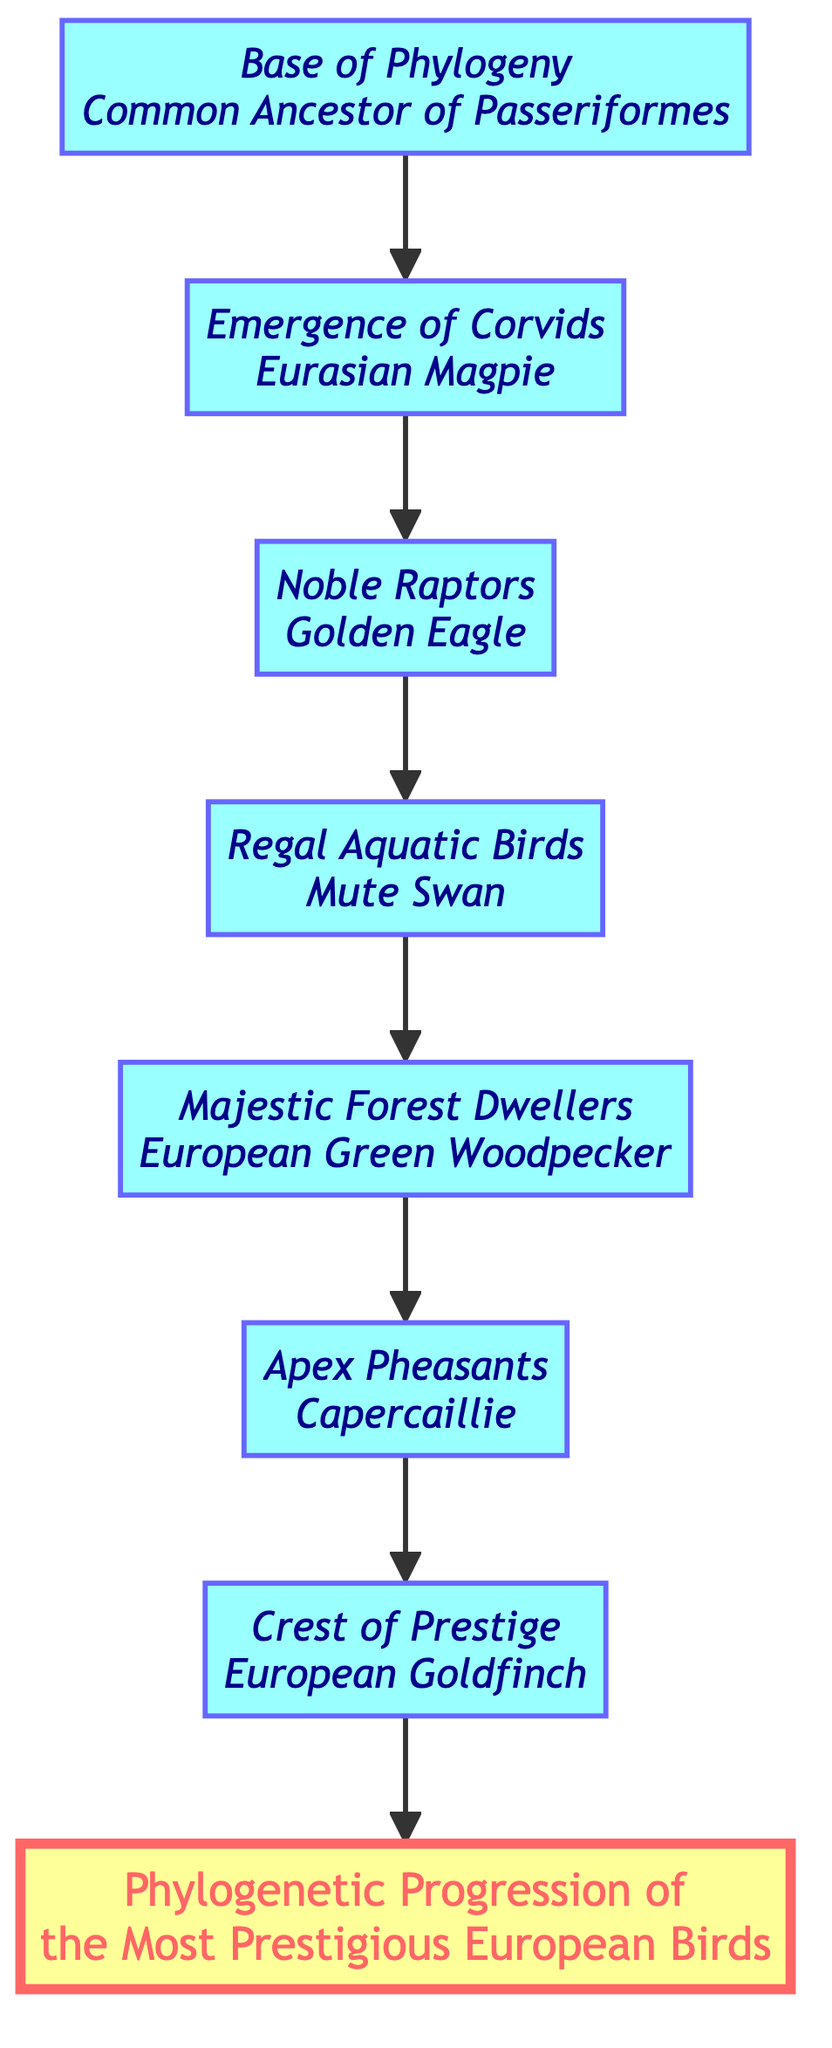What is the topmost element of the diagram? The topmost element is the title "Phylogenetic Progression of the Most Prestigious European Birds." It can be identified as the element that does not point to any other node and is at the highest level in the flow chart.
Answer: Phylogenetic Progression of the Most Prestigious European Birds Which bird is located at the base of the phylogeny? The base of the phylogeny is represented by the node for "Common Ancestor of Passeriformes." This is the first element from which other bird families evolved, as indicated in the diagram.
Answer: Common Ancestor of Passeriformes How many levels are represented in the chart? The diagram consists of 7 distinct levels, each representing a different stage of evolutionary progress among the prestigious European birds. Each step leads upward, showcasing the hierarchy.
Answer: 7 Which bird represents the emergence of Corvids? The diagram clearly states that the bird representing the emergence of Corvids is "Eurasian Magpie." It is directly connected to the base of phylogeny and is the first unique bird in the flowchart.
Answer: Eurasian Magpie What is the relationship between the Golden Eagle and the Mute Swan? In the diagram, the relationship is one of sequential hierarchy. The Golden Eagle is positioned directly below the Mute Swan, indicating that the Mute Swan comes after the Golden Eagle in the phylogenetic progression.
Answer: Sequential hierarchy Which bird is at the crest of prestige? According to the diagram, the bird at the crest of prestige is "European Goldfinch." It resides at the highest level of representation in the flow chart, signifying its top position in prestige among the listed birds.
Answer: European Goldfinch Name the bird known for its vibrant coloration and royal presence. The diagram indicates that the bird known for its vibrant coloration and royal presence is the "European Green Woodpecker." This information distinguishes it among other forest-dwelling birds.
Answer: European Green Woodpecker How many bird types are represented in the progression? The diagram illustrates 6 specific bird types following the base of phylogeny, each representing a unique evolutionary advancement in European birds. Each bird is part of a distinct category in the flow.
Answer: 6 What does the Golden Eagle symbolize in European culture? The diagram describes the Golden Eagle as a "symbol of power and nobility," clearly identifying its significance within European culture and avian hierarchy.
Answer: Power and nobility 